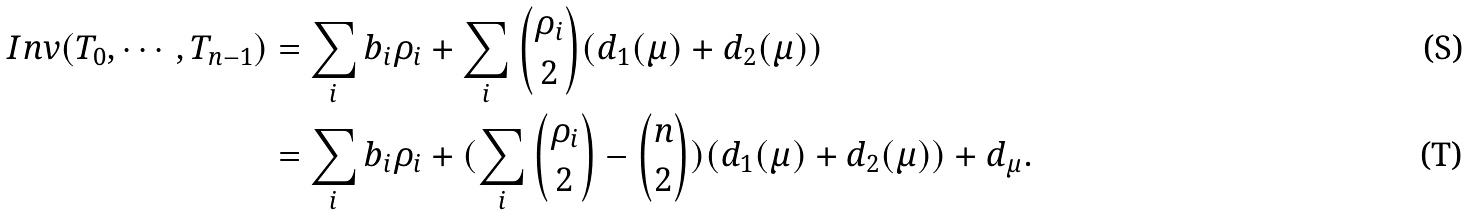Convert formula to latex. <formula><loc_0><loc_0><loc_500><loc_500>I n v ( T _ { 0 } , \cdots , T _ { n - 1 } ) & = \sum _ { i } b _ { i } \rho _ { i } + \sum _ { i } \binom { \rho _ { i } } { 2 } ( d _ { 1 } ( \mu ) + d _ { 2 } ( \mu ) ) \\ & = \sum _ { i } b _ { i } \rho _ { i } + ( \sum _ { i } \binom { \rho _ { i } } { 2 } - \binom { n } { 2 } ) ( d _ { 1 } ( \mu ) + d _ { 2 } ( \mu ) ) + d _ { \mu } .</formula> 